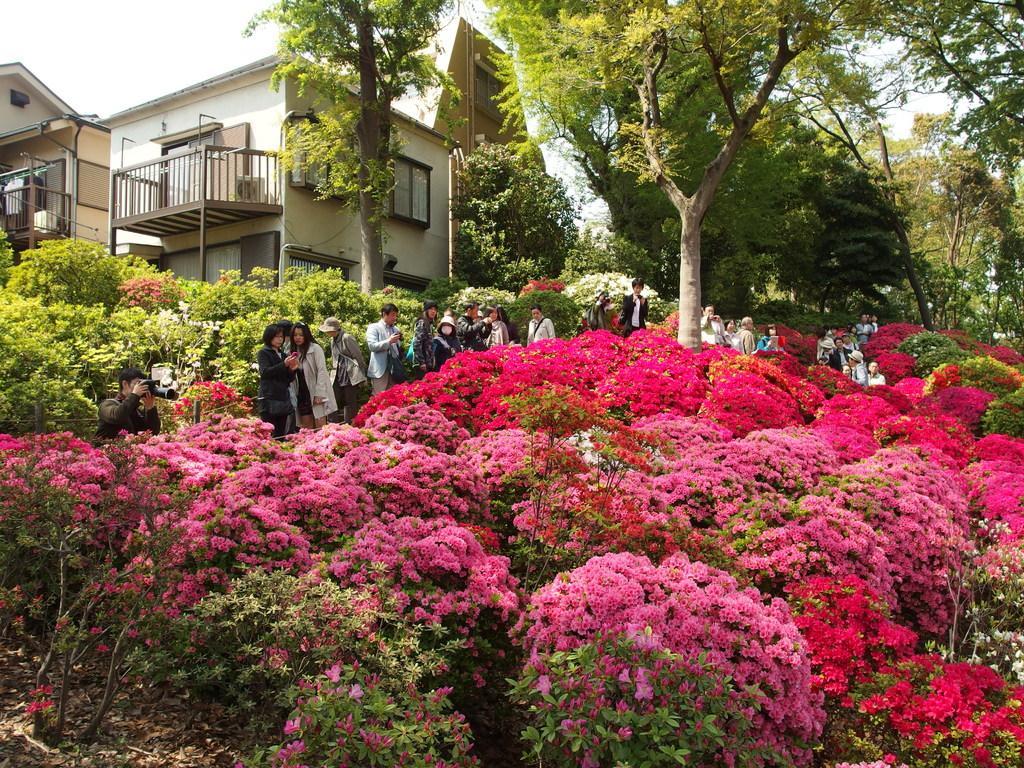Can you describe this image briefly? In this image there are flower plants, behind the flower plants there are people standing, in the background there are trees and houses. 